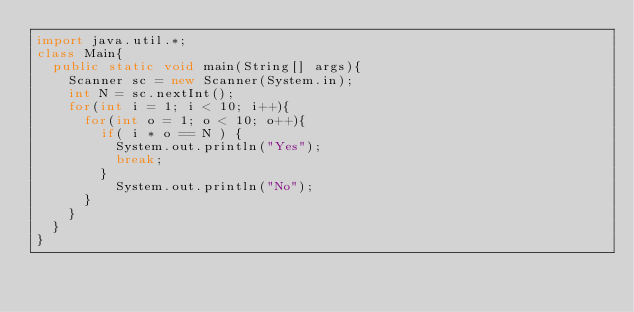Convert code to text. <code><loc_0><loc_0><loc_500><loc_500><_Java_>import java.util.*;
class Main{
  public static void main(String[] args){
    Scanner sc = new Scanner(System.in);
    int N = sc.nextInt();
    for(int i = 1; i < 10; i++){
      for(int o = 1; o < 10; o++){
        if( i * o == N ) {
          System.out.println("Yes");
          break;
        }
          System.out.println("No");
      }
    }
  }
}
</code> 